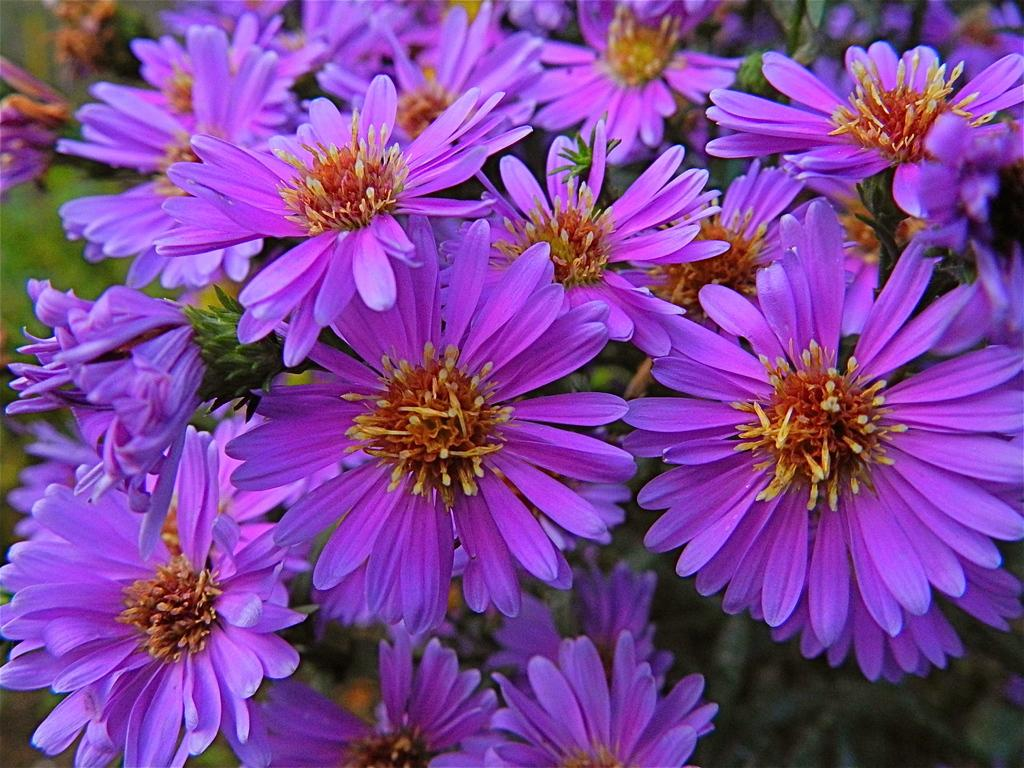What type of flora can be seen in the image? There are flowers in the image. What else can be seen in the background of the image? There are plants in the background of the image. How would you describe the clarity of the image? The image is blurry. What is the title of the destruction depicted in the image? There is no destruction depicted in the image, as it features flowers and plants. 